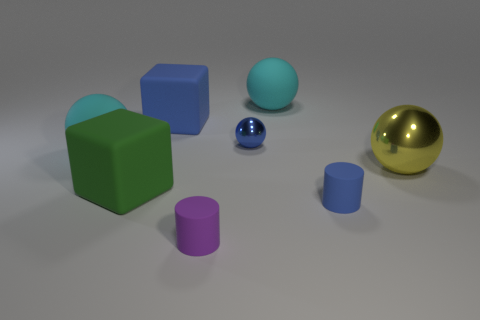Is the number of large matte balls behind the big green object the same as the number of large cyan balls in front of the tiny blue shiny object?
Give a very brief answer. No. How many matte cubes are there?
Make the answer very short. 2. Is the number of cyan spheres that are on the right side of the tiny purple cylinder greater than the number of tiny green rubber spheres?
Your answer should be compact. Yes. What material is the yellow object in front of the blue rubber block?
Offer a terse response. Metal. There is another shiny thing that is the same shape as the yellow object; what is its color?
Keep it short and to the point. Blue. What number of matte blocks have the same color as the large metal ball?
Make the answer very short. 0. There is a cyan matte object that is to the left of the small purple cylinder; is it the same size as the blue rubber cylinder that is on the right side of the big blue rubber block?
Your answer should be compact. No. Is the size of the purple rubber cylinder the same as the matte cylinder right of the purple cylinder?
Offer a terse response. Yes. What is the size of the green object?
Make the answer very short. Large. What color is the other small cylinder that is made of the same material as the tiny blue cylinder?
Provide a succinct answer. Purple. 